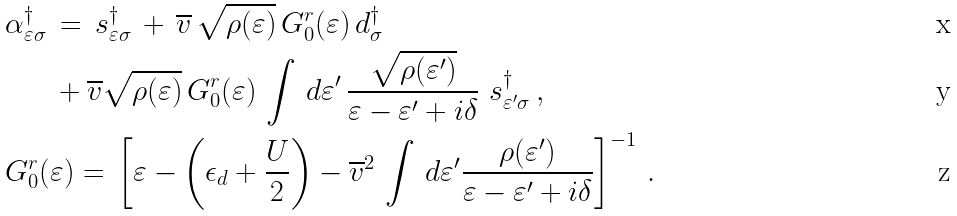Convert formula to latex. <formula><loc_0><loc_0><loc_500><loc_500>& \alpha _ { \varepsilon \sigma } ^ { \dagger } \, = \, s _ { \varepsilon \sigma } ^ { \dagger } \, + \, \overline { v } \, \sqrt { \rho ( \varepsilon ) } \, G ^ { r } _ { 0 } ( \varepsilon ) \, d _ { \sigma } ^ { \dagger } \, \\ & \quad \ \ + \overline { v } \sqrt { \rho ( \varepsilon ) } \, G ^ { r } _ { 0 } ( \varepsilon ) \, \int \, d \varepsilon ^ { \prime } \, \frac { \sqrt { \rho ( \varepsilon ^ { \prime } ) } } { \varepsilon - \varepsilon ^ { \prime } + i \delta } \ s _ { \varepsilon ^ { \prime } \sigma } ^ { \dagger } \, , \\ & G ^ { r } _ { 0 } ( \varepsilon ) = \, \left [ \varepsilon - \left ( \epsilon _ { d } + \frac { U } { 2 } \right ) - \overline { v } ^ { 2 } \, \int \, d \varepsilon ^ { \prime } \frac { \rho ( \varepsilon ^ { \prime } ) } { \varepsilon - \varepsilon ^ { \prime } + i \delta } \right ] ^ { - 1 } \, .</formula> 